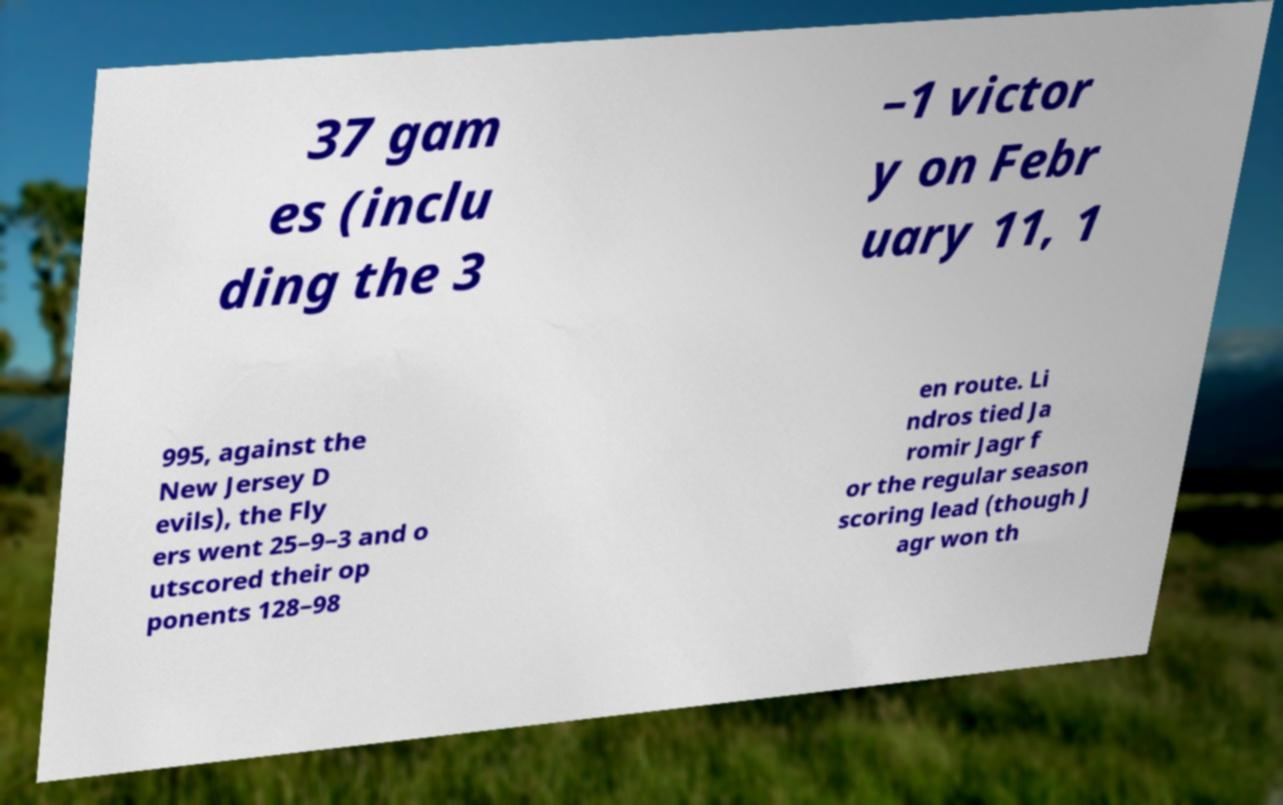For documentation purposes, I need the text within this image transcribed. Could you provide that? 37 gam es (inclu ding the 3 –1 victor y on Febr uary 11, 1 995, against the New Jersey D evils), the Fly ers went 25–9–3 and o utscored their op ponents 128–98 en route. Li ndros tied Ja romir Jagr f or the regular season scoring lead (though J agr won th 